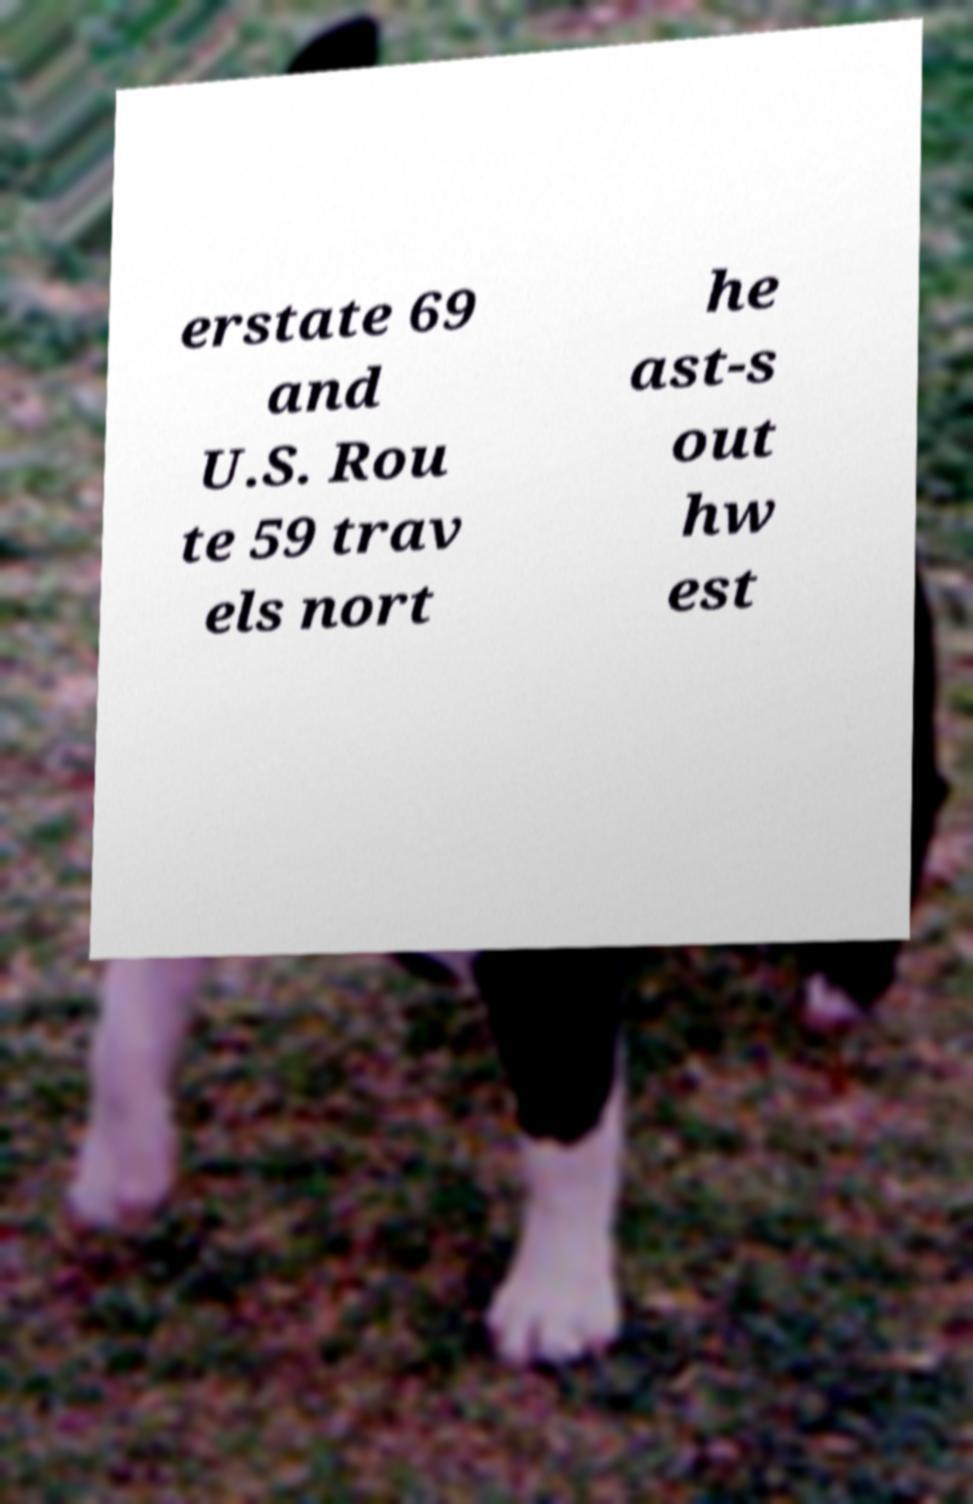Could you assist in decoding the text presented in this image and type it out clearly? erstate 69 and U.S. Rou te 59 trav els nort he ast-s out hw est 